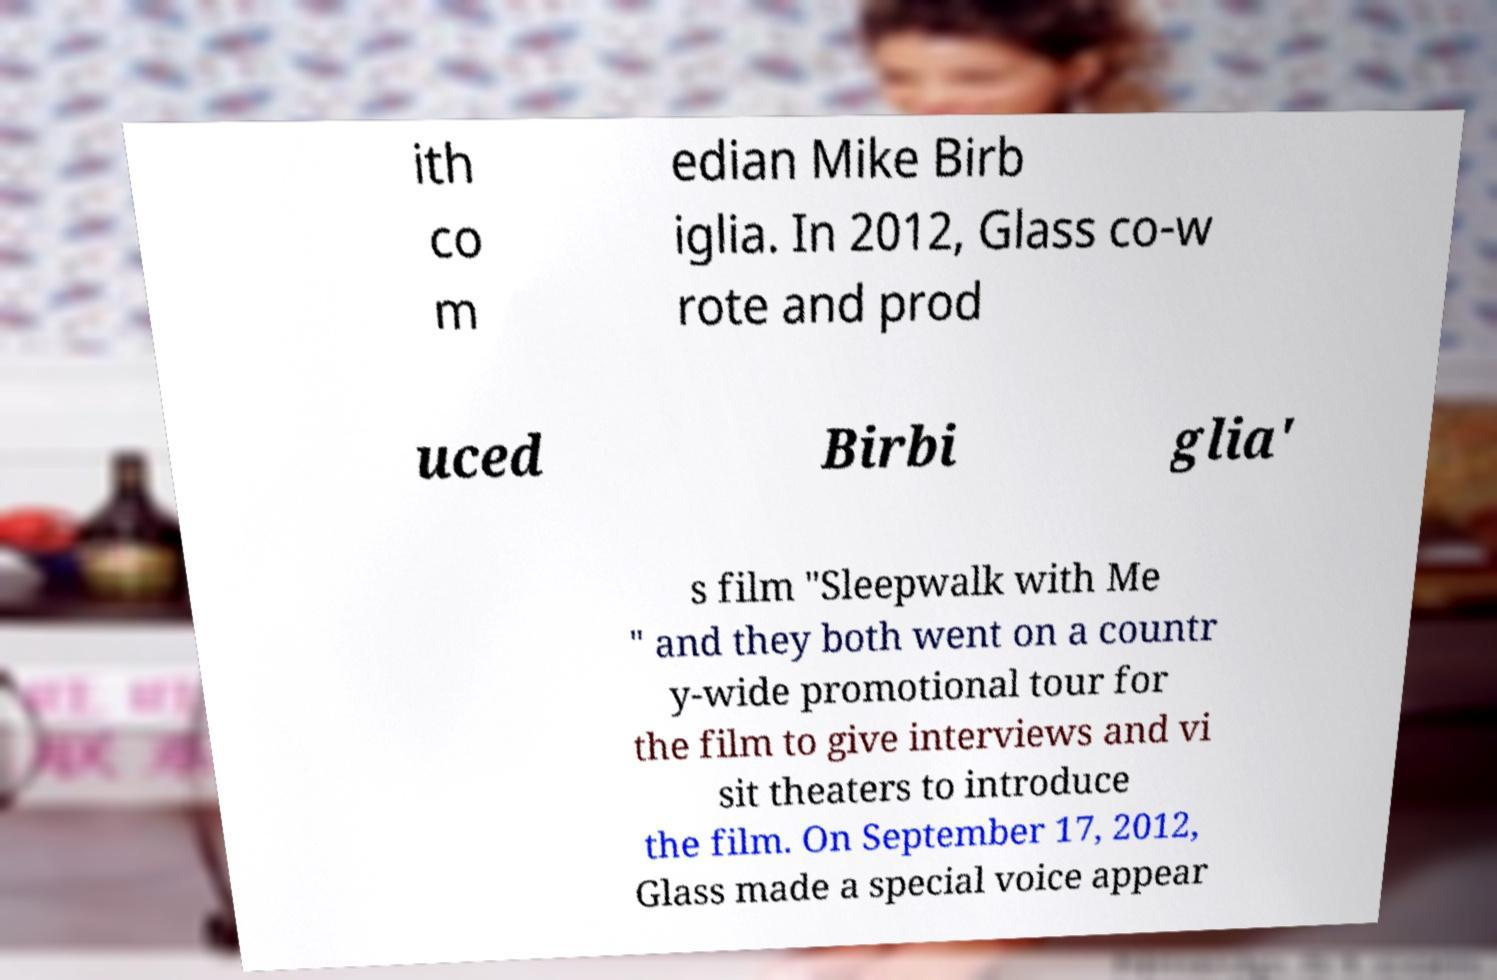Could you assist in decoding the text presented in this image and type it out clearly? ith co m edian Mike Birb iglia. In 2012, Glass co-w rote and prod uced Birbi glia' s film "Sleepwalk with Me " and they both went on a countr y-wide promotional tour for the film to give interviews and vi sit theaters to introduce the film. On September 17, 2012, Glass made a special voice appear 